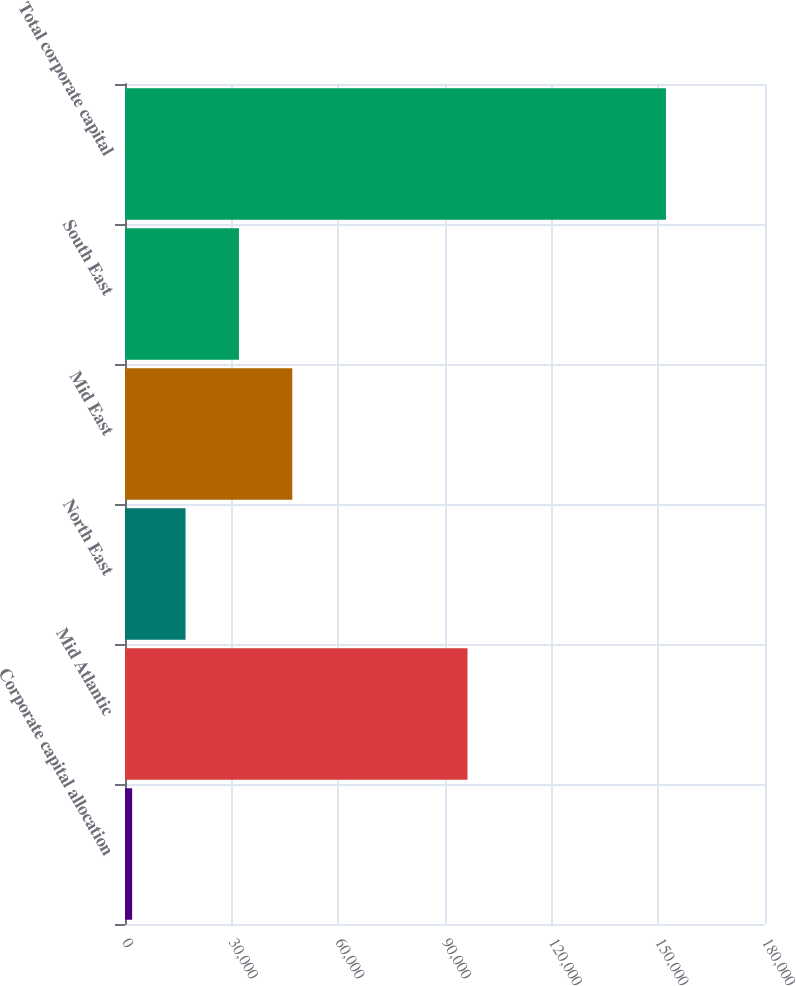Convert chart to OTSL. <chart><loc_0><loc_0><loc_500><loc_500><bar_chart><fcel>Corporate capital allocation<fcel>Mid Atlantic<fcel>North East<fcel>Mid East<fcel>South East<fcel>Total corporate capital<nl><fcel>2014<fcel>96328<fcel>17026.6<fcel>47051.8<fcel>32039.2<fcel>152140<nl></chart> 